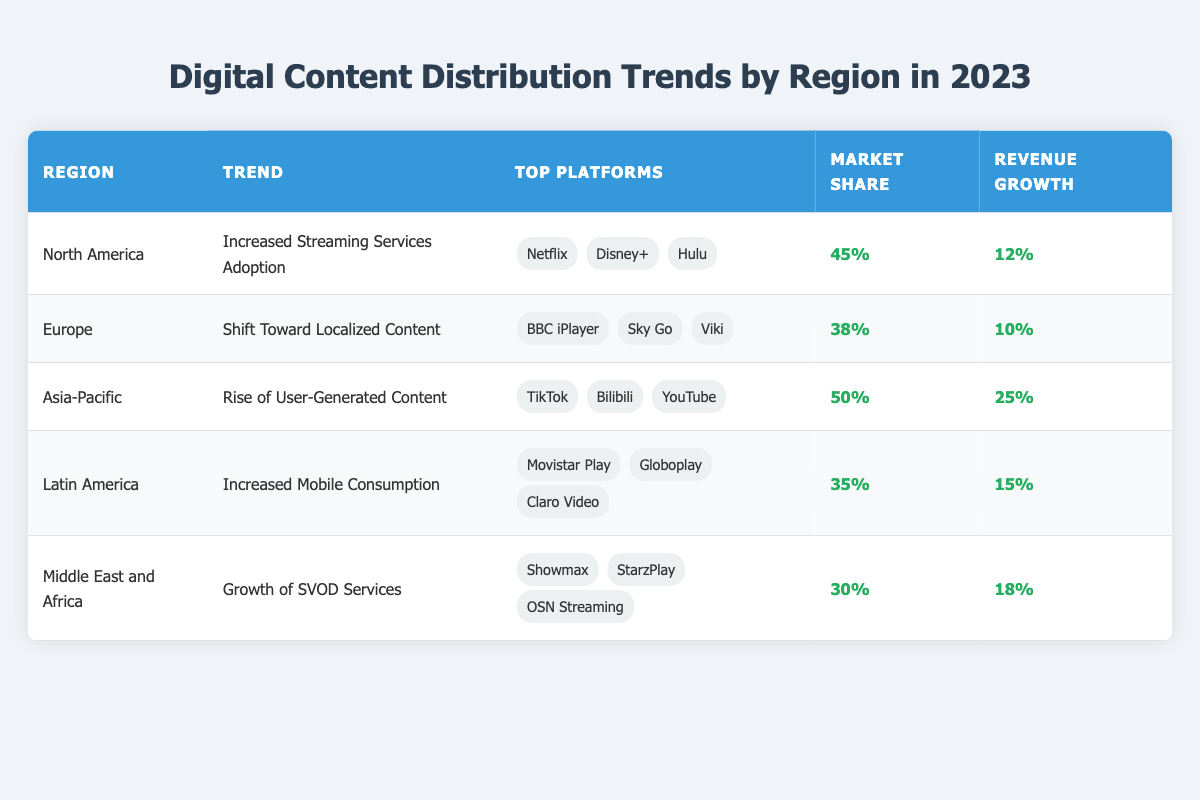What is the top platform in North America for digital content distribution in 2023? According to the table, the top platforms in North America are listed as Netflix, Disney+, and Hulu. Among these, Netflix is typically considered the leading platform due to its large subscriber base and extensive content library.
Answer: Netflix Which region has the highest market share for digital content distribution? By reviewing the market share percentages in the table, Asia-Pacific shows the highest market share at 50%.
Answer: Asia-Pacific What is the revenue growth percentage in Latin America? The table lists the revenue growth percentage for Latin America as 15%.
Answer: 15% Is the trend in Europe generally focused on localized content? Yes, the table specifies that Europe is experiencing a shift toward localized content as a key trend.
Answer: Yes What is the difference in market share between North America and Middle East and Africa? The market share for North America is 45%, while the Middle East and Africa is 30%. The difference is calculated as 45% - 30% = 15%.
Answer: 15% Which region has the lowest revenue growth percentage among the listed regions? A comparison of the revenue growth percentages shows that Europe has the lowest figure at 10%.
Answer: Europe If we combine the market shares of North America and Latin America, what would that total be? North America has a market share of 45% and Latin America has 35%. Adding these percentages gives 45% + 35% = 80%.
Answer: 80% What are the top three platforms in the Asia-Pacific region? According to the table, the top platforms in the Asia-Pacific region are TikTok, Bilibili, and YouTube.
Answer: TikTok, Bilibili, YouTube What is the revenue growth in the Middle East and Africa compared to the revenue growth in Latin America? The revenue growth for Middle East and Africa is 18% and for Latin America is 15%. The comparison shows that Middle East and Africa has a higher revenue growth of 3% when subtracted: 18% - 15% = 3%.
Answer: 3% Are there any regions with a market share below 35%? Yes, the Middle East and Africa region has a market share of 30%, which is below 35%.
Answer: Yes 